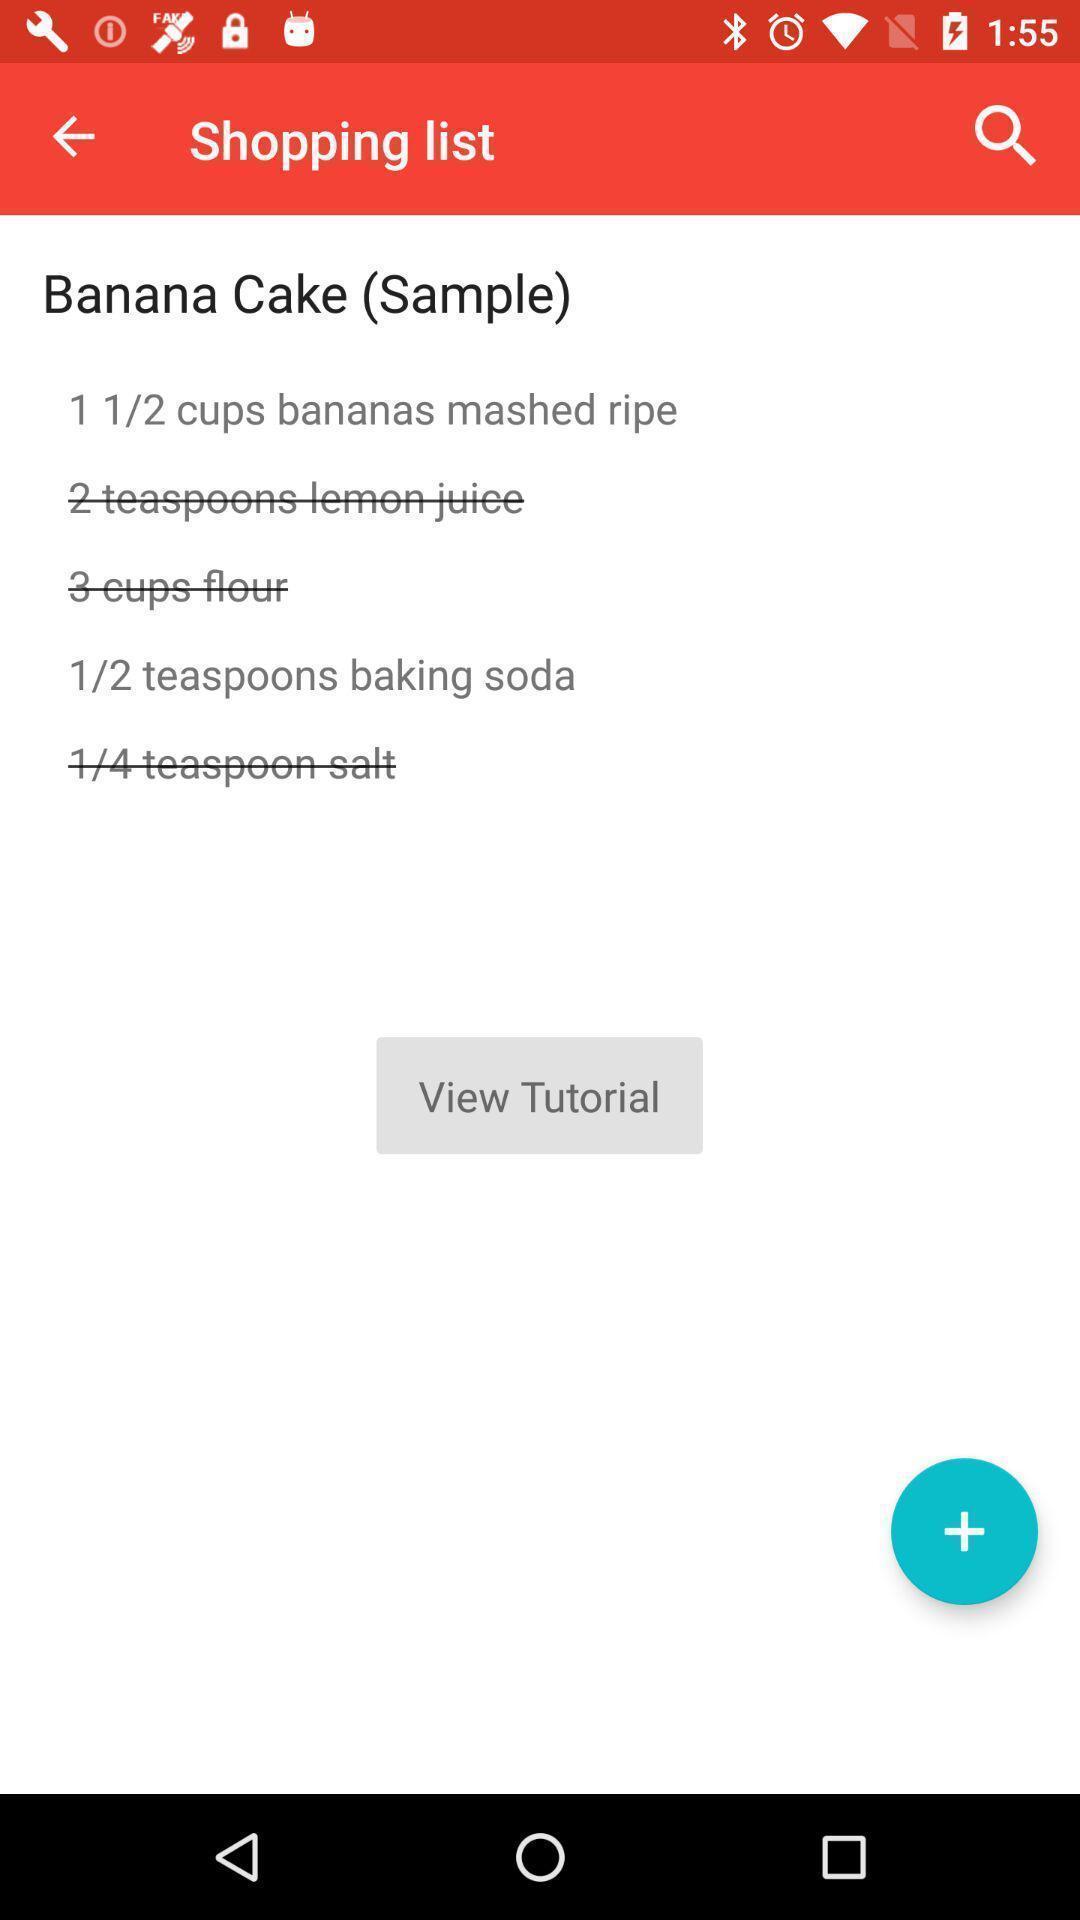Describe the visual elements of this screenshot. Page displays how to make a cake in recipe app. 